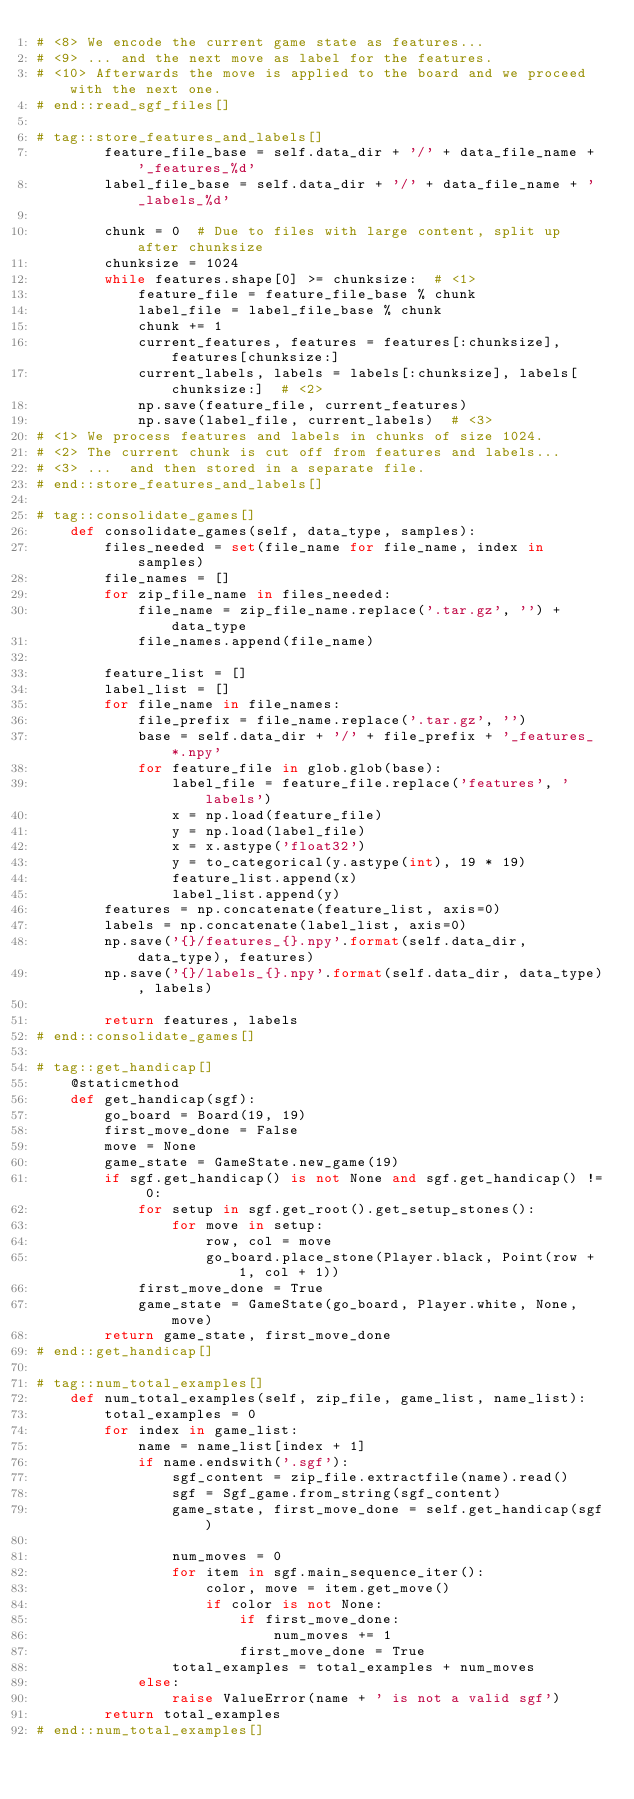Convert code to text. <code><loc_0><loc_0><loc_500><loc_500><_Python_># <8> We encode the current game state as features...
# <9> ... and the next move as label for the features.
# <10> Afterwards the move is applied to the board and we proceed with the next one.
# end::read_sgf_files[]

# tag::store_features_and_labels[]
        feature_file_base = self.data_dir + '/' + data_file_name + '_features_%d'
        label_file_base = self.data_dir + '/' + data_file_name + '_labels_%d'

        chunk = 0  # Due to files with large content, split up after chunksize
        chunksize = 1024
        while features.shape[0] >= chunksize:  # <1>
            feature_file = feature_file_base % chunk
            label_file = label_file_base % chunk
            chunk += 1
            current_features, features = features[:chunksize], features[chunksize:]
            current_labels, labels = labels[:chunksize], labels[chunksize:]  # <2>
            np.save(feature_file, current_features)
            np.save(label_file, current_labels)  # <3>
# <1> We process features and labels in chunks of size 1024.
# <2> The current chunk is cut off from features and labels...
# <3> ...  and then stored in a separate file.
# end::store_features_and_labels[]

# tag::consolidate_games[]
    def consolidate_games(self, data_type, samples):
        files_needed = set(file_name for file_name, index in samples)
        file_names = []
        for zip_file_name in files_needed:
            file_name = zip_file_name.replace('.tar.gz', '') + data_type
            file_names.append(file_name)

        feature_list = []
        label_list = []
        for file_name in file_names:
            file_prefix = file_name.replace('.tar.gz', '')
            base = self.data_dir + '/' + file_prefix + '_features_*.npy'
            for feature_file in glob.glob(base):
                label_file = feature_file.replace('features', 'labels')
                x = np.load(feature_file)
                y = np.load(label_file)
                x = x.astype('float32')
                y = to_categorical(y.astype(int), 19 * 19)
                feature_list.append(x)
                label_list.append(y)
        features = np.concatenate(feature_list, axis=0)
        labels = np.concatenate(label_list, axis=0)
        np.save('{}/features_{}.npy'.format(self.data_dir, data_type), features)
        np.save('{}/labels_{}.npy'.format(self.data_dir, data_type), labels)

        return features, labels
# end::consolidate_games[]

# tag::get_handicap[]
    @staticmethod
    def get_handicap(sgf):
        go_board = Board(19, 19)
        first_move_done = False
        move = None
        game_state = GameState.new_game(19)
        if sgf.get_handicap() is not None and sgf.get_handicap() != 0:
            for setup in sgf.get_root().get_setup_stones():
                for move in setup:
                    row, col = move
                    go_board.place_stone(Player.black, Point(row + 1, col + 1))
            first_move_done = True
            game_state = GameState(go_board, Player.white, None, move)
        return game_state, first_move_done
# end::get_handicap[]

# tag::num_total_examples[]
    def num_total_examples(self, zip_file, game_list, name_list):
        total_examples = 0
        for index in game_list:
            name = name_list[index + 1]
            if name.endswith('.sgf'):
                sgf_content = zip_file.extractfile(name).read()
                sgf = Sgf_game.from_string(sgf_content)
                game_state, first_move_done = self.get_handicap(sgf)

                num_moves = 0
                for item in sgf.main_sequence_iter():
                    color, move = item.get_move()
                    if color is not None:
                        if first_move_done:
                            num_moves += 1
                        first_move_done = True
                total_examples = total_examples + num_moves
            else:
                raise ValueError(name + ' is not a valid sgf')
        return total_examples
# end::num_total_examples[]
</code> 